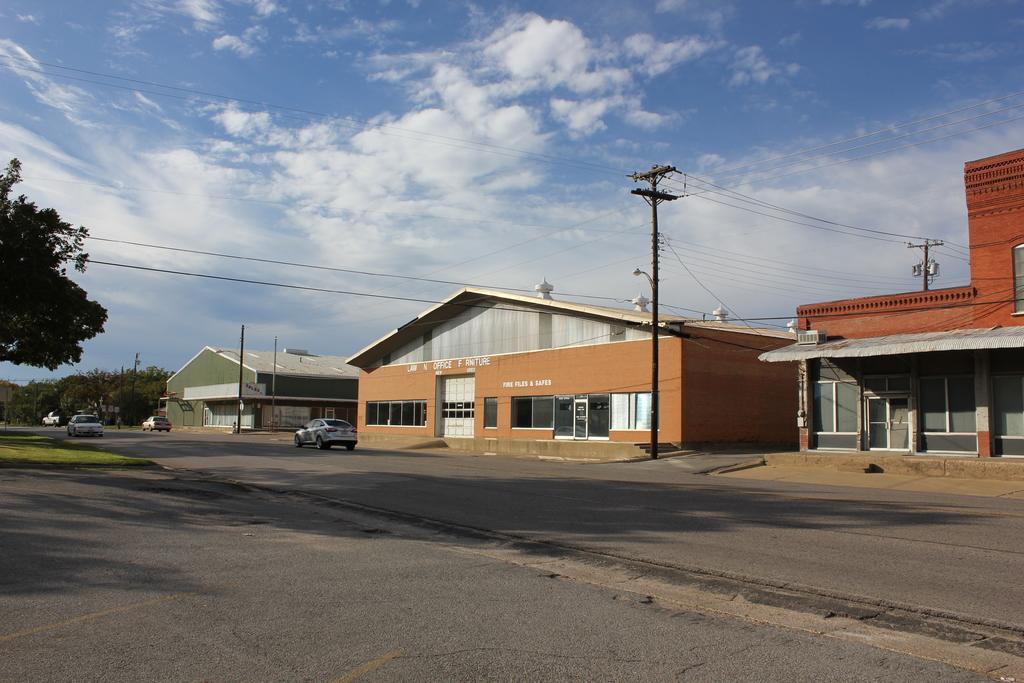Can you describe this image briefly? This picture is clicked outside. On the left we can see the group of cars running on the road and we can see the small portion of green grass. On the right we can see the houses and the windows of the houses. In the background we can see the sky, trees, poles and cables. 